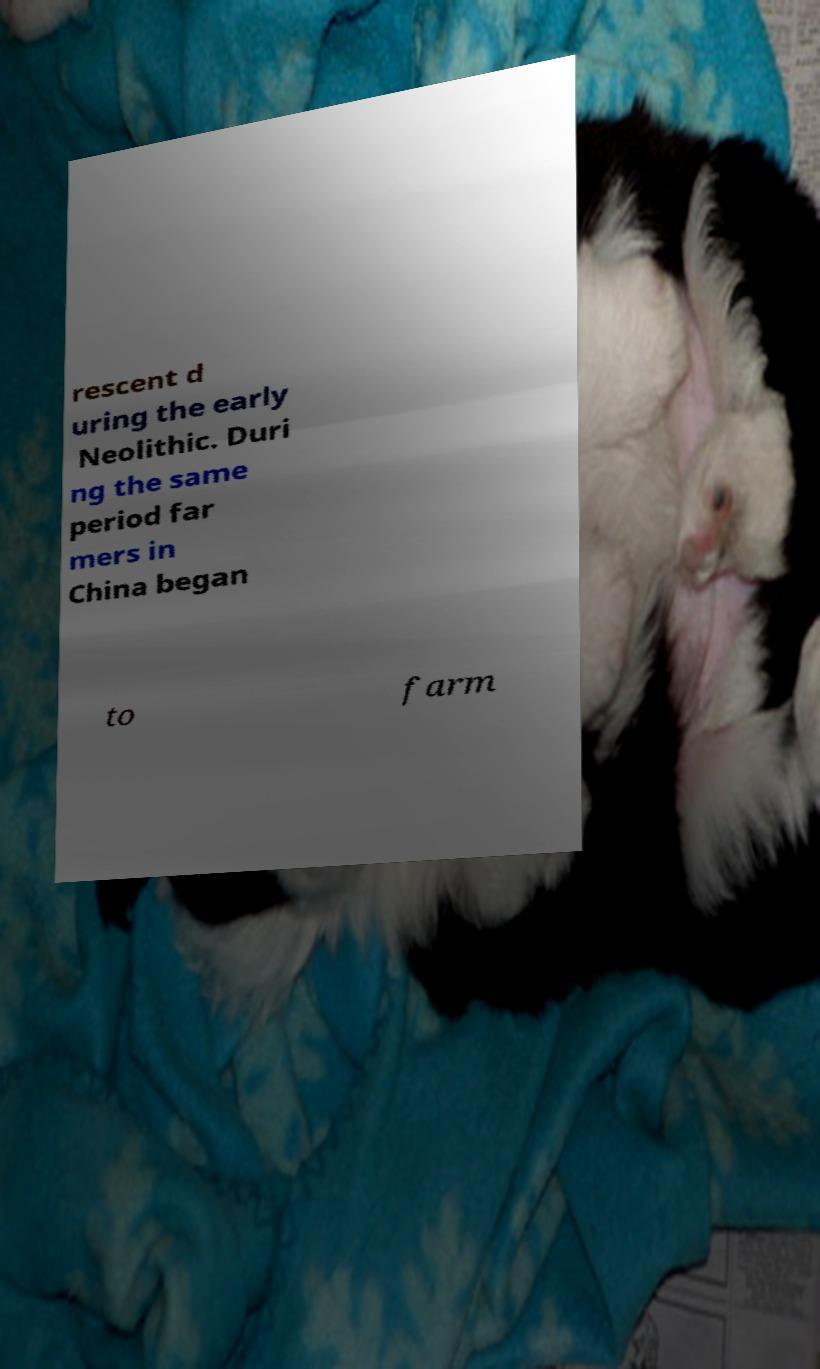What messages or text are displayed in this image? I need them in a readable, typed format. rescent d uring the early Neolithic. Duri ng the same period far mers in China began to farm 